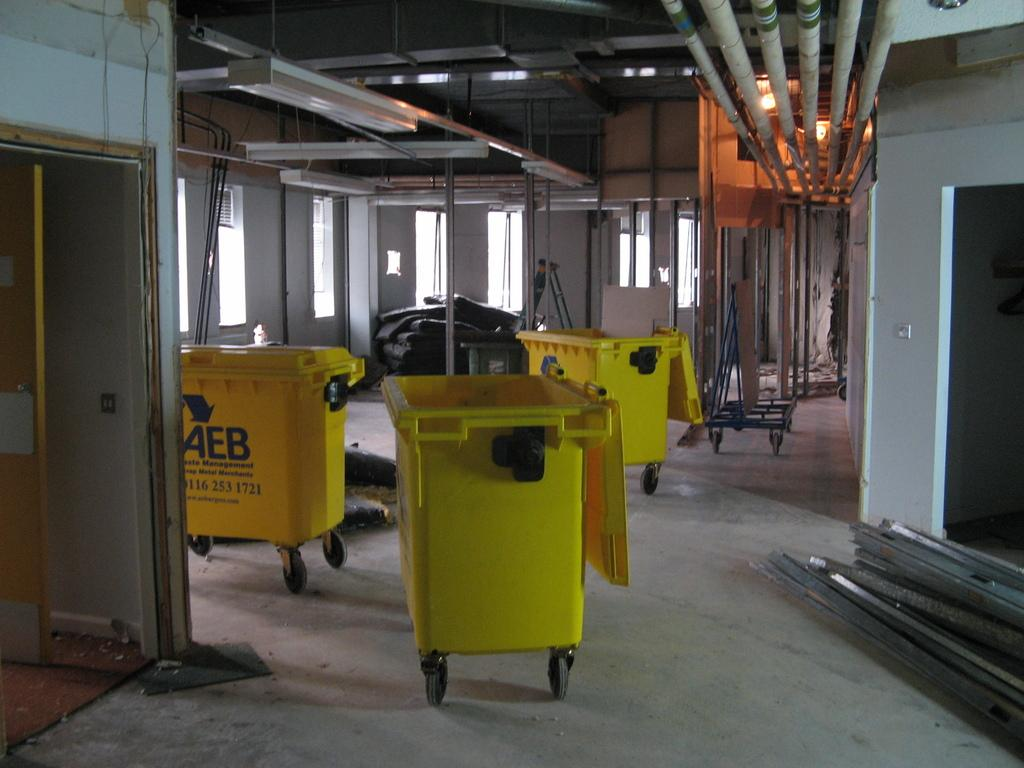<image>
Give a short and clear explanation of the subsequent image. Three trash bins on wheels with "AEB" written on them are positioned in a building under construction. 